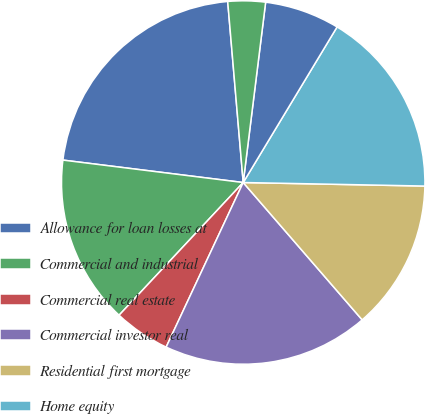<chart> <loc_0><loc_0><loc_500><loc_500><pie_chart><fcel>Allowance for loan losses at<fcel>Commercial and industrial<fcel>Commercial real estate<fcel>Commercial investor real<fcel>Residential first mortgage<fcel>Home equity<fcel>Indirect<fcel>Other consumer<nl><fcel>21.67%<fcel>15.0%<fcel>5.0%<fcel>18.33%<fcel>13.33%<fcel>16.67%<fcel>6.67%<fcel>3.33%<nl></chart> 